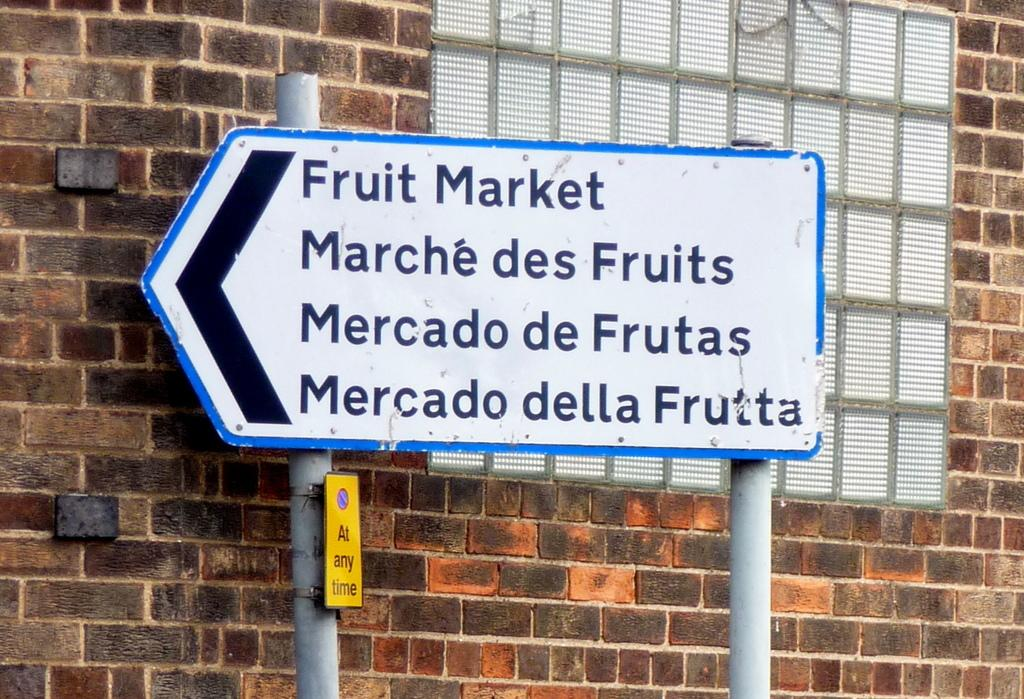<image>
Summarize the visual content of the image. A sign against a brick building shows that a fruit market is to the left. 